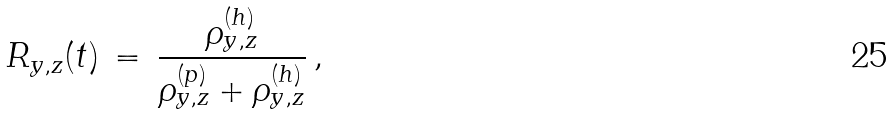Convert formula to latex. <formula><loc_0><loc_0><loc_500><loc_500>R _ { y , z } ( t ) \, = \, \frac { \rho _ { y , z } ^ { ( h ) } } { \rho _ { y , z } ^ { ( p ) } + \rho _ { y , z } ^ { ( h ) } } \, ,</formula> 